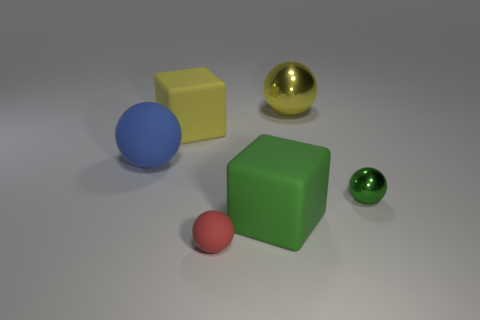Add 2 big yellow blocks. How many objects exist? 8 Subtract all big blue balls. How many balls are left? 3 Subtract all blue spheres. How many spheres are left? 3 Subtract all spheres. How many objects are left? 2 Subtract 1 cubes. How many cubes are left? 1 Subtract all large cubes. Subtract all tiny rubber things. How many objects are left? 3 Add 1 cubes. How many cubes are left? 3 Add 3 big rubber blocks. How many big rubber blocks exist? 5 Subtract 0 brown cylinders. How many objects are left? 6 Subtract all yellow cubes. Subtract all brown balls. How many cubes are left? 1 